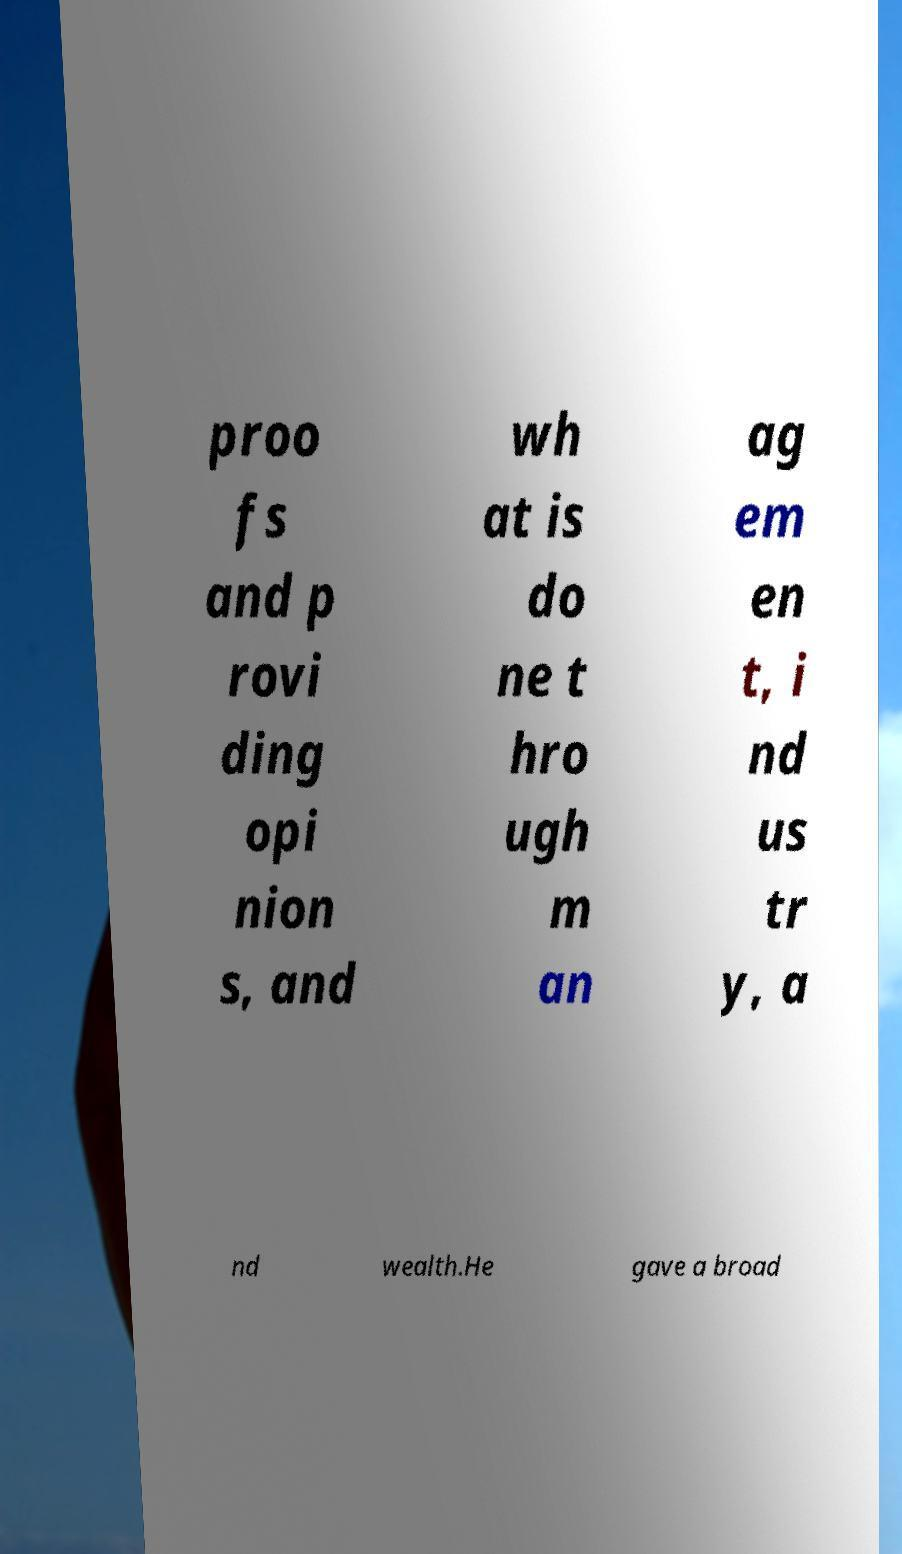Can you accurately transcribe the text from the provided image for me? proo fs and p rovi ding opi nion s, and wh at is do ne t hro ugh m an ag em en t, i nd us tr y, a nd wealth.He gave a broad 